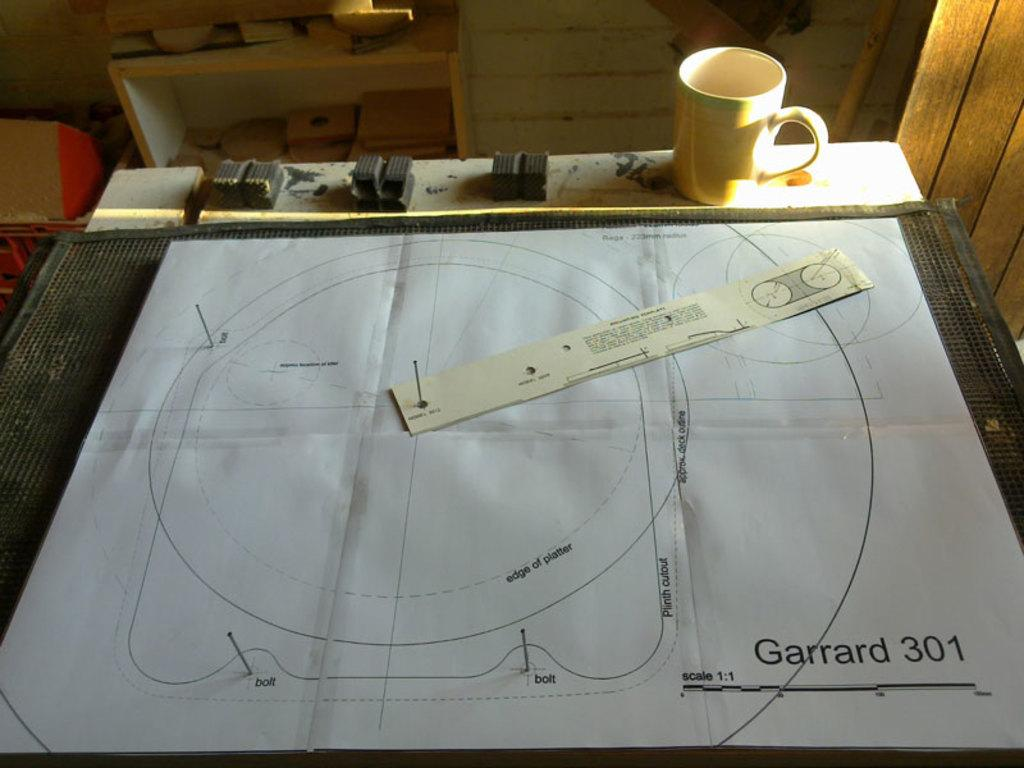<image>
Present a compact description of the photo's key features. A drawing with Garrard 301 in the lower right corner. 